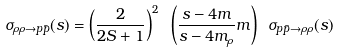<formula> <loc_0><loc_0><loc_500><loc_500>\sigma _ { \rho \rho \rightarrow p \bar { p } } ( s ) = \left ( \frac { 2 } { 2 S + 1 } \right ) ^ { 2 } \ \left ( \frac { s - 4 m } { s - 4 m _ { \rho } } m \right ) \ \sigma _ { p \bar { p } \rightarrow \rho \rho } ( s )</formula> 